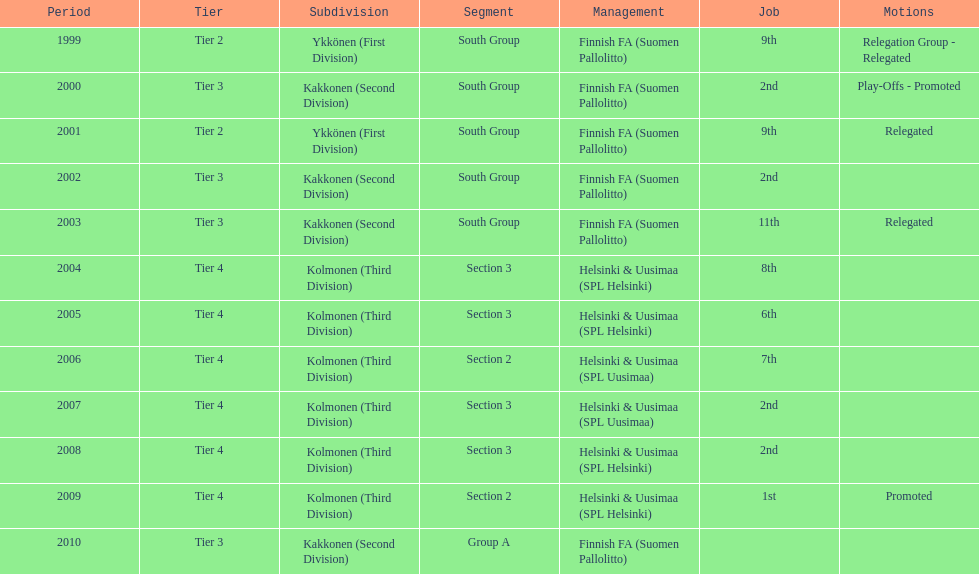How many 2nd positions were there? 4. 